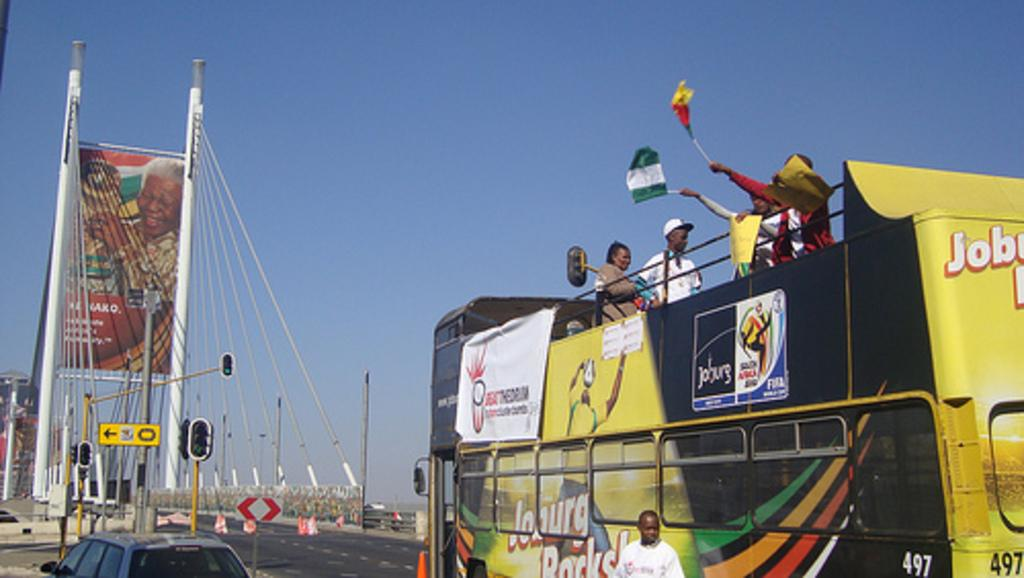What mode of transportation are the people in the image using? The people are present in a bus. What are the people holding in the image? The people are holding flags. What can be seen on the left side of the image? There is a car on the left side of the image. What is located at the back of the image? There is a hoarding at the back of the image. What objects are present in the image that support infrastructure? There are poles and traffic signals in the image. What is visible at the top of the image? The sky is visible at the top of the image. How many stones can be seen in the image? There are no stones present in the image. Is there a giraffe visible in the image? No, there is no giraffe present in the image. 